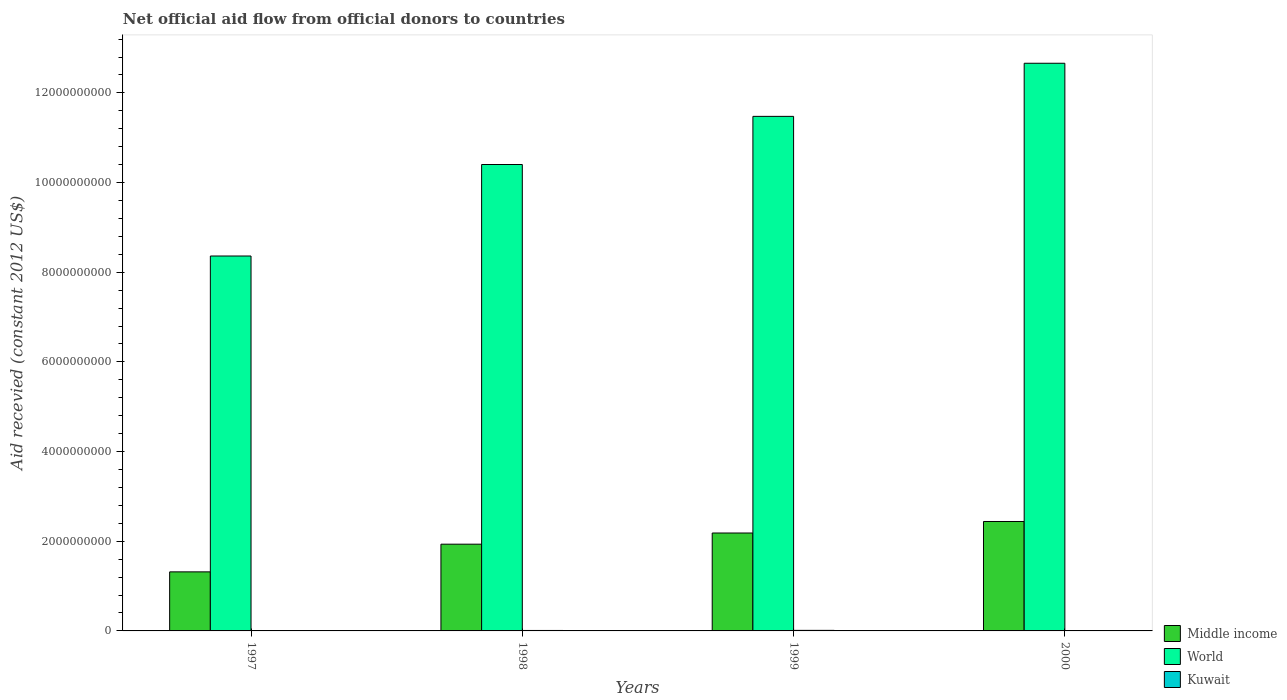Are the number of bars per tick equal to the number of legend labels?
Provide a short and direct response. Yes. How many bars are there on the 1st tick from the left?
Provide a succinct answer. 3. How many bars are there on the 4th tick from the right?
Make the answer very short. 3. What is the label of the 2nd group of bars from the left?
Your answer should be very brief. 1998. What is the total aid received in Kuwait in 1997?
Provide a short and direct response. 1.85e+06. Across all years, what is the maximum total aid received in Middle income?
Ensure brevity in your answer.  2.44e+09. Across all years, what is the minimum total aid received in World?
Give a very brief answer. 8.36e+09. In which year was the total aid received in Kuwait minimum?
Provide a succinct answer. 1997. What is the total total aid received in Kuwait in the graph?
Offer a terse response. 3.05e+07. What is the difference between the total aid received in Kuwait in 1997 and that in 1999?
Give a very brief answer. -1.05e+07. What is the difference between the total aid received in Middle income in 2000 and the total aid received in Kuwait in 1997?
Ensure brevity in your answer.  2.44e+09. What is the average total aid received in Middle income per year?
Keep it short and to the point. 1.97e+09. In the year 1997, what is the difference between the total aid received in World and total aid received in Middle income?
Ensure brevity in your answer.  7.04e+09. In how many years, is the total aid received in World greater than 8800000000 US$?
Provide a succinct answer. 3. What is the ratio of the total aid received in Middle income in 1997 to that in 1998?
Your answer should be very brief. 0.68. Is the total aid received in Kuwait in 1997 less than that in 1998?
Give a very brief answer. Yes. Is the difference between the total aid received in World in 1997 and 1998 greater than the difference between the total aid received in Middle income in 1997 and 1998?
Provide a succinct answer. No. What is the difference between the highest and the second highest total aid received in Middle income?
Make the answer very short. 2.57e+08. What is the difference between the highest and the lowest total aid received in Kuwait?
Offer a very short reply. 1.05e+07. In how many years, is the total aid received in World greater than the average total aid received in World taken over all years?
Offer a very short reply. 2. What does the 1st bar from the right in 1998 represents?
Make the answer very short. Kuwait. Are all the bars in the graph horizontal?
Offer a very short reply. No. How many years are there in the graph?
Offer a terse response. 4. Does the graph contain any zero values?
Provide a succinct answer. No. What is the title of the graph?
Your response must be concise. Net official aid flow from official donors to countries. What is the label or title of the Y-axis?
Ensure brevity in your answer.  Aid recevied (constant 2012 US$). What is the Aid recevied (constant 2012 US$) in Middle income in 1997?
Give a very brief answer. 1.32e+09. What is the Aid recevied (constant 2012 US$) in World in 1997?
Your response must be concise. 8.36e+09. What is the Aid recevied (constant 2012 US$) of Kuwait in 1997?
Keep it short and to the point. 1.85e+06. What is the Aid recevied (constant 2012 US$) of Middle income in 1998?
Your answer should be compact. 1.93e+09. What is the Aid recevied (constant 2012 US$) in World in 1998?
Your answer should be very brief. 1.04e+1. What is the Aid recevied (constant 2012 US$) of Kuwait in 1998?
Provide a short and direct response. 1.01e+07. What is the Aid recevied (constant 2012 US$) of Middle income in 1999?
Provide a succinct answer. 2.18e+09. What is the Aid recevied (constant 2012 US$) in World in 1999?
Make the answer very short. 1.15e+1. What is the Aid recevied (constant 2012 US$) in Kuwait in 1999?
Provide a short and direct response. 1.23e+07. What is the Aid recevied (constant 2012 US$) of Middle income in 2000?
Ensure brevity in your answer.  2.44e+09. What is the Aid recevied (constant 2012 US$) in World in 2000?
Your response must be concise. 1.27e+1. What is the Aid recevied (constant 2012 US$) in Kuwait in 2000?
Give a very brief answer. 6.19e+06. Across all years, what is the maximum Aid recevied (constant 2012 US$) in Middle income?
Your response must be concise. 2.44e+09. Across all years, what is the maximum Aid recevied (constant 2012 US$) of World?
Keep it short and to the point. 1.27e+1. Across all years, what is the maximum Aid recevied (constant 2012 US$) in Kuwait?
Offer a terse response. 1.23e+07. Across all years, what is the minimum Aid recevied (constant 2012 US$) in Middle income?
Provide a succinct answer. 1.32e+09. Across all years, what is the minimum Aid recevied (constant 2012 US$) in World?
Make the answer very short. 8.36e+09. Across all years, what is the minimum Aid recevied (constant 2012 US$) in Kuwait?
Offer a terse response. 1.85e+06. What is the total Aid recevied (constant 2012 US$) in Middle income in the graph?
Give a very brief answer. 7.88e+09. What is the total Aid recevied (constant 2012 US$) of World in the graph?
Your answer should be very brief. 4.29e+1. What is the total Aid recevied (constant 2012 US$) of Kuwait in the graph?
Offer a very short reply. 3.05e+07. What is the difference between the Aid recevied (constant 2012 US$) in Middle income in 1997 and that in 1998?
Your answer should be compact. -6.18e+08. What is the difference between the Aid recevied (constant 2012 US$) of World in 1997 and that in 1998?
Ensure brevity in your answer.  -2.04e+09. What is the difference between the Aid recevied (constant 2012 US$) of Kuwait in 1997 and that in 1998?
Your answer should be very brief. -8.28e+06. What is the difference between the Aid recevied (constant 2012 US$) in Middle income in 1997 and that in 1999?
Make the answer very short. -8.67e+08. What is the difference between the Aid recevied (constant 2012 US$) of World in 1997 and that in 1999?
Make the answer very short. -3.11e+09. What is the difference between the Aid recevied (constant 2012 US$) in Kuwait in 1997 and that in 1999?
Your response must be concise. -1.05e+07. What is the difference between the Aid recevied (constant 2012 US$) in Middle income in 1997 and that in 2000?
Your response must be concise. -1.12e+09. What is the difference between the Aid recevied (constant 2012 US$) of World in 1997 and that in 2000?
Offer a very short reply. -4.30e+09. What is the difference between the Aid recevied (constant 2012 US$) in Kuwait in 1997 and that in 2000?
Your response must be concise. -4.34e+06. What is the difference between the Aid recevied (constant 2012 US$) in Middle income in 1998 and that in 1999?
Offer a terse response. -2.49e+08. What is the difference between the Aid recevied (constant 2012 US$) of World in 1998 and that in 1999?
Give a very brief answer. -1.07e+09. What is the difference between the Aid recevied (constant 2012 US$) in Kuwait in 1998 and that in 1999?
Your answer should be compact. -2.20e+06. What is the difference between the Aid recevied (constant 2012 US$) in Middle income in 1998 and that in 2000?
Your answer should be very brief. -5.06e+08. What is the difference between the Aid recevied (constant 2012 US$) in World in 1998 and that in 2000?
Provide a succinct answer. -2.26e+09. What is the difference between the Aid recevied (constant 2012 US$) of Kuwait in 1998 and that in 2000?
Offer a very short reply. 3.94e+06. What is the difference between the Aid recevied (constant 2012 US$) in Middle income in 1999 and that in 2000?
Your answer should be compact. -2.57e+08. What is the difference between the Aid recevied (constant 2012 US$) of World in 1999 and that in 2000?
Your answer should be compact. -1.18e+09. What is the difference between the Aid recevied (constant 2012 US$) in Kuwait in 1999 and that in 2000?
Keep it short and to the point. 6.14e+06. What is the difference between the Aid recevied (constant 2012 US$) in Middle income in 1997 and the Aid recevied (constant 2012 US$) in World in 1998?
Keep it short and to the point. -9.09e+09. What is the difference between the Aid recevied (constant 2012 US$) of Middle income in 1997 and the Aid recevied (constant 2012 US$) of Kuwait in 1998?
Your answer should be very brief. 1.31e+09. What is the difference between the Aid recevied (constant 2012 US$) of World in 1997 and the Aid recevied (constant 2012 US$) of Kuwait in 1998?
Offer a very short reply. 8.35e+09. What is the difference between the Aid recevied (constant 2012 US$) in Middle income in 1997 and the Aid recevied (constant 2012 US$) in World in 1999?
Give a very brief answer. -1.02e+1. What is the difference between the Aid recevied (constant 2012 US$) of Middle income in 1997 and the Aid recevied (constant 2012 US$) of Kuwait in 1999?
Your answer should be compact. 1.30e+09. What is the difference between the Aid recevied (constant 2012 US$) of World in 1997 and the Aid recevied (constant 2012 US$) of Kuwait in 1999?
Offer a very short reply. 8.35e+09. What is the difference between the Aid recevied (constant 2012 US$) of Middle income in 1997 and the Aid recevied (constant 2012 US$) of World in 2000?
Your answer should be compact. -1.13e+1. What is the difference between the Aid recevied (constant 2012 US$) in Middle income in 1997 and the Aid recevied (constant 2012 US$) in Kuwait in 2000?
Make the answer very short. 1.31e+09. What is the difference between the Aid recevied (constant 2012 US$) of World in 1997 and the Aid recevied (constant 2012 US$) of Kuwait in 2000?
Offer a very short reply. 8.36e+09. What is the difference between the Aid recevied (constant 2012 US$) of Middle income in 1998 and the Aid recevied (constant 2012 US$) of World in 1999?
Ensure brevity in your answer.  -9.54e+09. What is the difference between the Aid recevied (constant 2012 US$) of Middle income in 1998 and the Aid recevied (constant 2012 US$) of Kuwait in 1999?
Give a very brief answer. 1.92e+09. What is the difference between the Aid recevied (constant 2012 US$) of World in 1998 and the Aid recevied (constant 2012 US$) of Kuwait in 1999?
Your answer should be very brief. 1.04e+1. What is the difference between the Aid recevied (constant 2012 US$) of Middle income in 1998 and the Aid recevied (constant 2012 US$) of World in 2000?
Ensure brevity in your answer.  -1.07e+1. What is the difference between the Aid recevied (constant 2012 US$) of Middle income in 1998 and the Aid recevied (constant 2012 US$) of Kuwait in 2000?
Keep it short and to the point. 1.93e+09. What is the difference between the Aid recevied (constant 2012 US$) in World in 1998 and the Aid recevied (constant 2012 US$) in Kuwait in 2000?
Keep it short and to the point. 1.04e+1. What is the difference between the Aid recevied (constant 2012 US$) in Middle income in 1999 and the Aid recevied (constant 2012 US$) in World in 2000?
Give a very brief answer. -1.05e+1. What is the difference between the Aid recevied (constant 2012 US$) of Middle income in 1999 and the Aid recevied (constant 2012 US$) of Kuwait in 2000?
Give a very brief answer. 2.18e+09. What is the difference between the Aid recevied (constant 2012 US$) in World in 1999 and the Aid recevied (constant 2012 US$) in Kuwait in 2000?
Your response must be concise. 1.15e+1. What is the average Aid recevied (constant 2012 US$) in Middle income per year?
Ensure brevity in your answer.  1.97e+09. What is the average Aid recevied (constant 2012 US$) of World per year?
Provide a short and direct response. 1.07e+1. What is the average Aid recevied (constant 2012 US$) in Kuwait per year?
Ensure brevity in your answer.  7.62e+06. In the year 1997, what is the difference between the Aid recevied (constant 2012 US$) in Middle income and Aid recevied (constant 2012 US$) in World?
Keep it short and to the point. -7.04e+09. In the year 1997, what is the difference between the Aid recevied (constant 2012 US$) in Middle income and Aid recevied (constant 2012 US$) in Kuwait?
Your answer should be very brief. 1.32e+09. In the year 1997, what is the difference between the Aid recevied (constant 2012 US$) of World and Aid recevied (constant 2012 US$) of Kuwait?
Provide a succinct answer. 8.36e+09. In the year 1998, what is the difference between the Aid recevied (constant 2012 US$) of Middle income and Aid recevied (constant 2012 US$) of World?
Provide a short and direct response. -8.47e+09. In the year 1998, what is the difference between the Aid recevied (constant 2012 US$) of Middle income and Aid recevied (constant 2012 US$) of Kuwait?
Make the answer very short. 1.92e+09. In the year 1998, what is the difference between the Aid recevied (constant 2012 US$) of World and Aid recevied (constant 2012 US$) of Kuwait?
Provide a short and direct response. 1.04e+1. In the year 1999, what is the difference between the Aid recevied (constant 2012 US$) of Middle income and Aid recevied (constant 2012 US$) of World?
Your response must be concise. -9.29e+09. In the year 1999, what is the difference between the Aid recevied (constant 2012 US$) in Middle income and Aid recevied (constant 2012 US$) in Kuwait?
Ensure brevity in your answer.  2.17e+09. In the year 1999, what is the difference between the Aid recevied (constant 2012 US$) of World and Aid recevied (constant 2012 US$) of Kuwait?
Your response must be concise. 1.15e+1. In the year 2000, what is the difference between the Aid recevied (constant 2012 US$) in Middle income and Aid recevied (constant 2012 US$) in World?
Your answer should be compact. -1.02e+1. In the year 2000, what is the difference between the Aid recevied (constant 2012 US$) in Middle income and Aid recevied (constant 2012 US$) in Kuwait?
Your answer should be compact. 2.43e+09. In the year 2000, what is the difference between the Aid recevied (constant 2012 US$) of World and Aid recevied (constant 2012 US$) of Kuwait?
Keep it short and to the point. 1.27e+1. What is the ratio of the Aid recevied (constant 2012 US$) of Middle income in 1997 to that in 1998?
Keep it short and to the point. 0.68. What is the ratio of the Aid recevied (constant 2012 US$) in World in 1997 to that in 1998?
Make the answer very short. 0.8. What is the ratio of the Aid recevied (constant 2012 US$) of Kuwait in 1997 to that in 1998?
Your answer should be very brief. 0.18. What is the ratio of the Aid recevied (constant 2012 US$) of Middle income in 1997 to that in 1999?
Your answer should be very brief. 0.6. What is the ratio of the Aid recevied (constant 2012 US$) of World in 1997 to that in 1999?
Your response must be concise. 0.73. What is the ratio of the Aid recevied (constant 2012 US$) in Middle income in 1997 to that in 2000?
Your answer should be very brief. 0.54. What is the ratio of the Aid recevied (constant 2012 US$) of World in 1997 to that in 2000?
Keep it short and to the point. 0.66. What is the ratio of the Aid recevied (constant 2012 US$) in Kuwait in 1997 to that in 2000?
Provide a succinct answer. 0.3. What is the ratio of the Aid recevied (constant 2012 US$) of Middle income in 1998 to that in 1999?
Provide a short and direct response. 0.89. What is the ratio of the Aid recevied (constant 2012 US$) of World in 1998 to that in 1999?
Make the answer very short. 0.91. What is the ratio of the Aid recevied (constant 2012 US$) of Kuwait in 1998 to that in 1999?
Offer a terse response. 0.82. What is the ratio of the Aid recevied (constant 2012 US$) of Middle income in 1998 to that in 2000?
Give a very brief answer. 0.79. What is the ratio of the Aid recevied (constant 2012 US$) of World in 1998 to that in 2000?
Your answer should be very brief. 0.82. What is the ratio of the Aid recevied (constant 2012 US$) of Kuwait in 1998 to that in 2000?
Keep it short and to the point. 1.64. What is the ratio of the Aid recevied (constant 2012 US$) in Middle income in 1999 to that in 2000?
Offer a terse response. 0.89. What is the ratio of the Aid recevied (constant 2012 US$) in World in 1999 to that in 2000?
Your answer should be compact. 0.91. What is the ratio of the Aid recevied (constant 2012 US$) in Kuwait in 1999 to that in 2000?
Your response must be concise. 1.99. What is the difference between the highest and the second highest Aid recevied (constant 2012 US$) of Middle income?
Ensure brevity in your answer.  2.57e+08. What is the difference between the highest and the second highest Aid recevied (constant 2012 US$) of World?
Keep it short and to the point. 1.18e+09. What is the difference between the highest and the second highest Aid recevied (constant 2012 US$) in Kuwait?
Provide a succinct answer. 2.20e+06. What is the difference between the highest and the lowest Aid recevied (constant 2012 US$) of Middle income?
Give a very brief answer. 1.12e+09. What is the difference between the highest and the lowest Aid recevied (constant 2012 US$) in World?
Give a very brief answer. 4.30e+09. What is the difference between the highest and the lowest Aid recevied (constant 2012 US$) in Kuwait?
Your answer should be compact. 1.05e+07. 